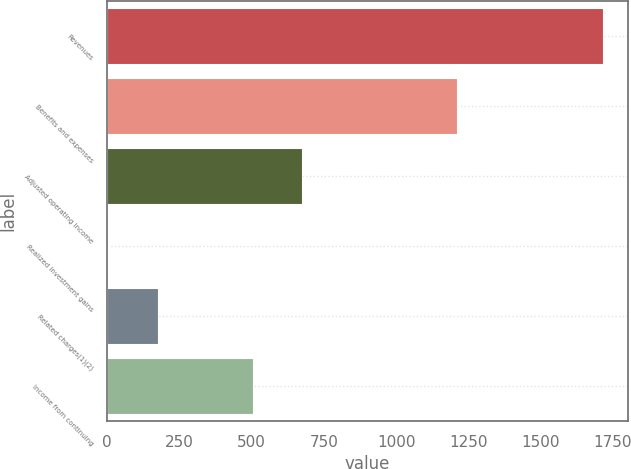<chart> <loc_0><loc_0><loc_500><loc_500><bar_chart><fcel>Revenues<fcel>Benefits and expenses<fcel>Adjusted operating income<fcel>Realized investment gains<fcel>Related charges(1)(2)<fcel>Income from continuing<nl><fcel>1717<fcel>1212<fcel>674.4<fcel>3<fcel>174.4<fcel>503<nl></chart> 